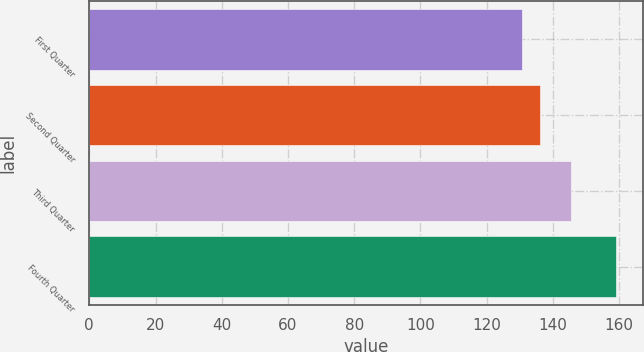<chart> <loc_0><loc_0><loc_500><loc_500><bar_chart><fcel>First Quarter<fcel>Second Quarter<fcel>Third Quarter<fcel>Fourth Quarter<nl><fcel>130.64<fcel>135.97<fcel>145.51<fcel>159.13<nl></chart> 